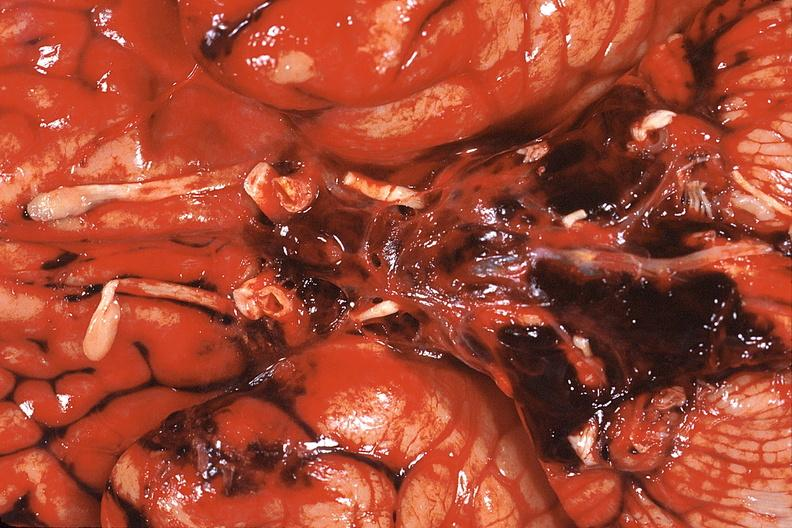s nervous present?
Answer the question using a single word or phrase. Yes 